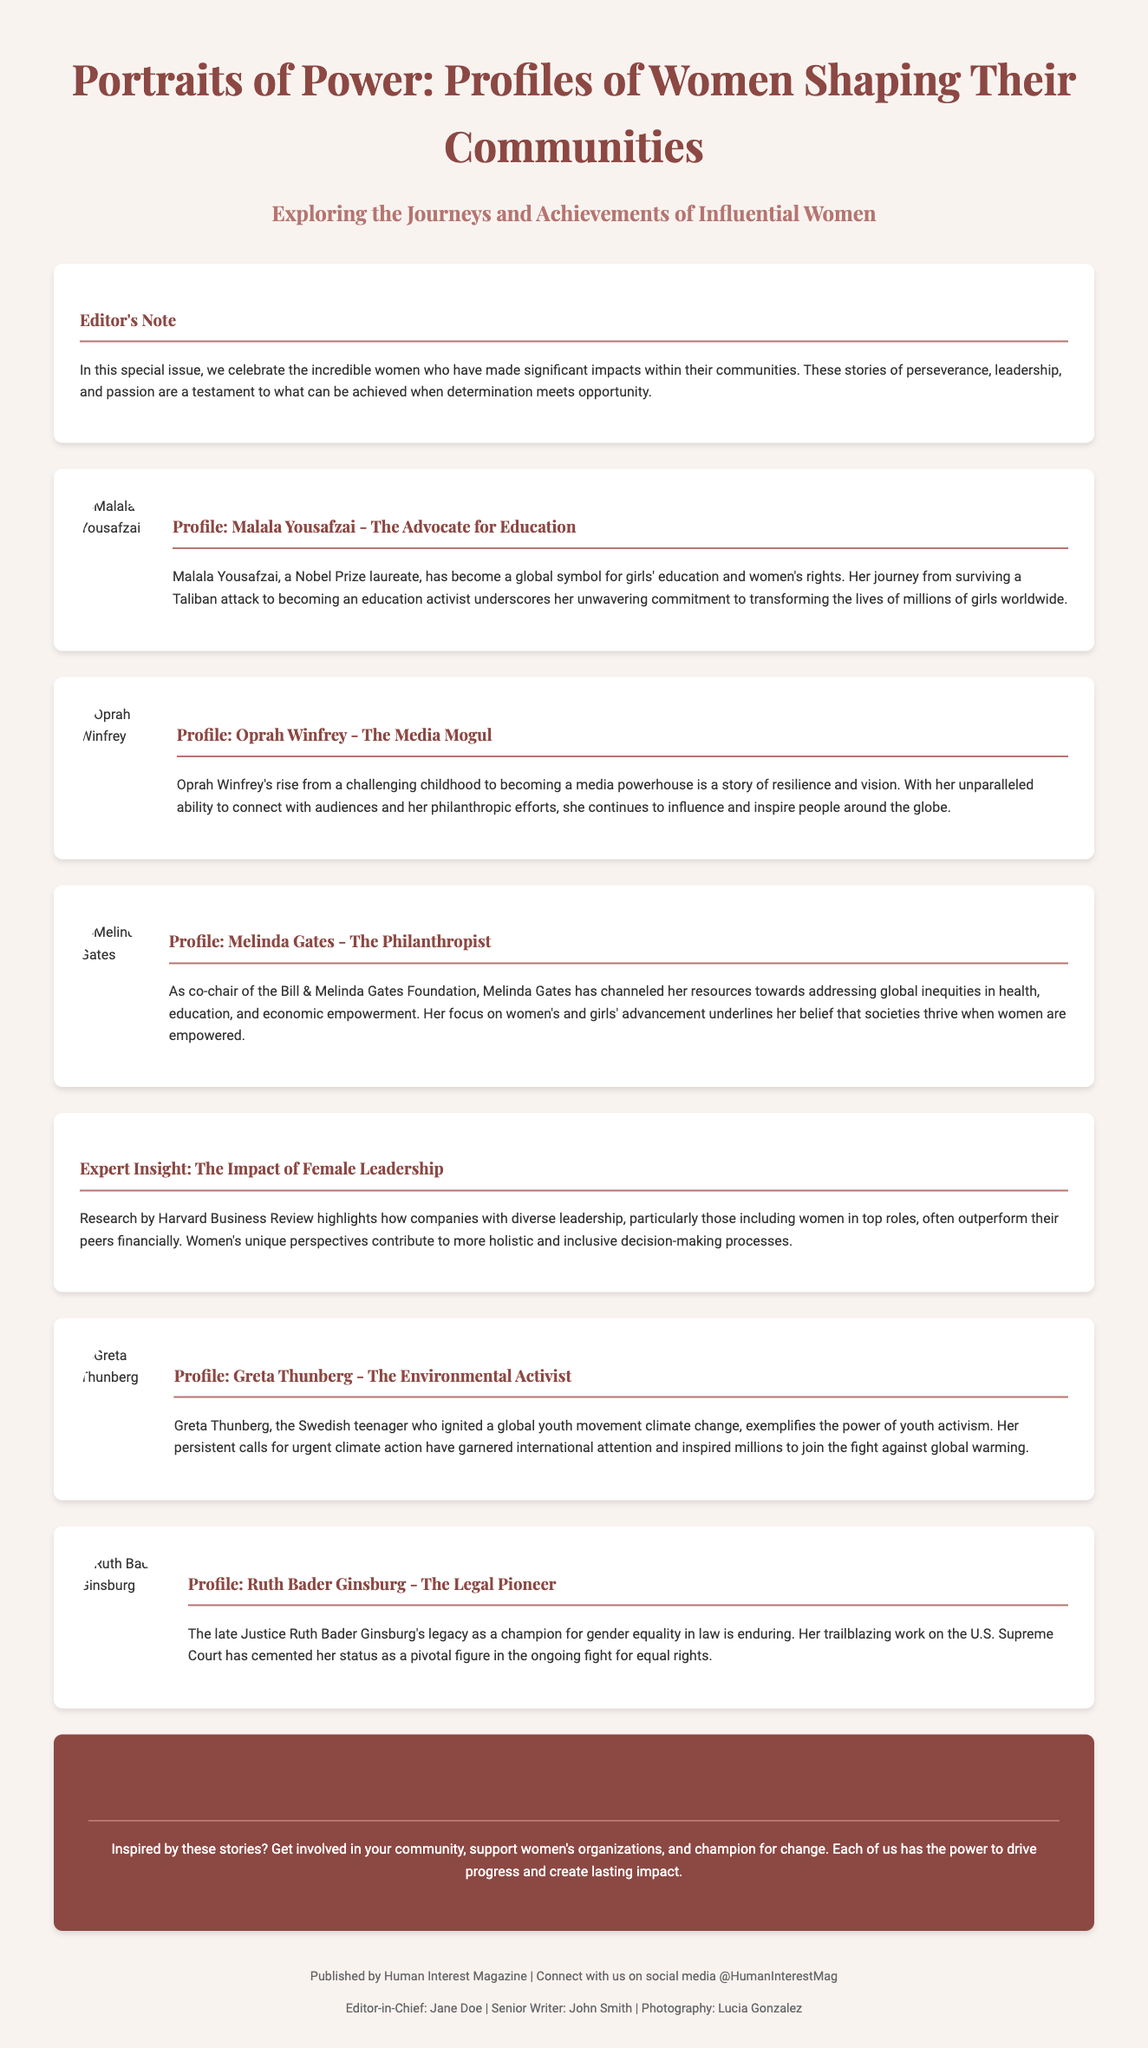What is the title of the magazine? The title is presented prominently at the top of the document.
Answer: Portraits of Power: Profiles of Women Shaping Their Communities Who is the first profile featured in the magazine? The first profile is listed with imagery and information about the individual.
Answer: Malala Yousafzai What is Malala Yousafzai known for? The document states her significant role and achievements.
Answer: Advocate for Education How many profiles are included in the magazine? The document lists six profiles about influential women.
Answer: Six What type of insight is provided in the magazine? The document includes expert insights focusing on leadership.
Answer: The Impact of Female Leadership What specific action does the Call to Action encourage? The Call to Action section urges readers to participate in community efforts.
Answer: Get involved in your community What is the overarching theme of the magazine? The theme is reflected in the editor's note and throughout the profiles.
Answer: Women shaping their communities Who is the Editor-in-Chief? The document lists key personnel involved in the magazine's publication.
Answer: Jane Doe 